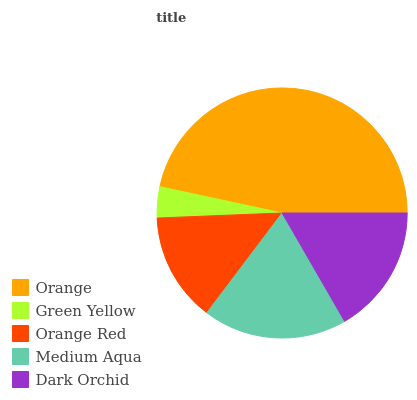Is Green Yellow the minimum?
Answer yes or no. Yes. Is Orange the maximum?
Answer yes or no. Yes. Is Orange Red the minimum?
Answer yes or no. No. Is Orange Red the maximum?
Answer yes or no. No. Is Orange Red greater than Green Yellow?
Answer yes or no. Yes. Is Green Yellow less than Orange Red?
Answer yes or no. Yes. Is Green Yellow greater than Orange Red?
Answer yes or no. No. Is Orange Red less than Green Yellow?
Answer yes or no. No. Is Dark Orchid the high median?
Answer yes or no. Yes. Is Dark Orchid the low median?
Answer yes or no. Yes. Is Green Yellow the high median?
Answer yes or no. No. Is Orange the low median?
Answer yes or no. No. 